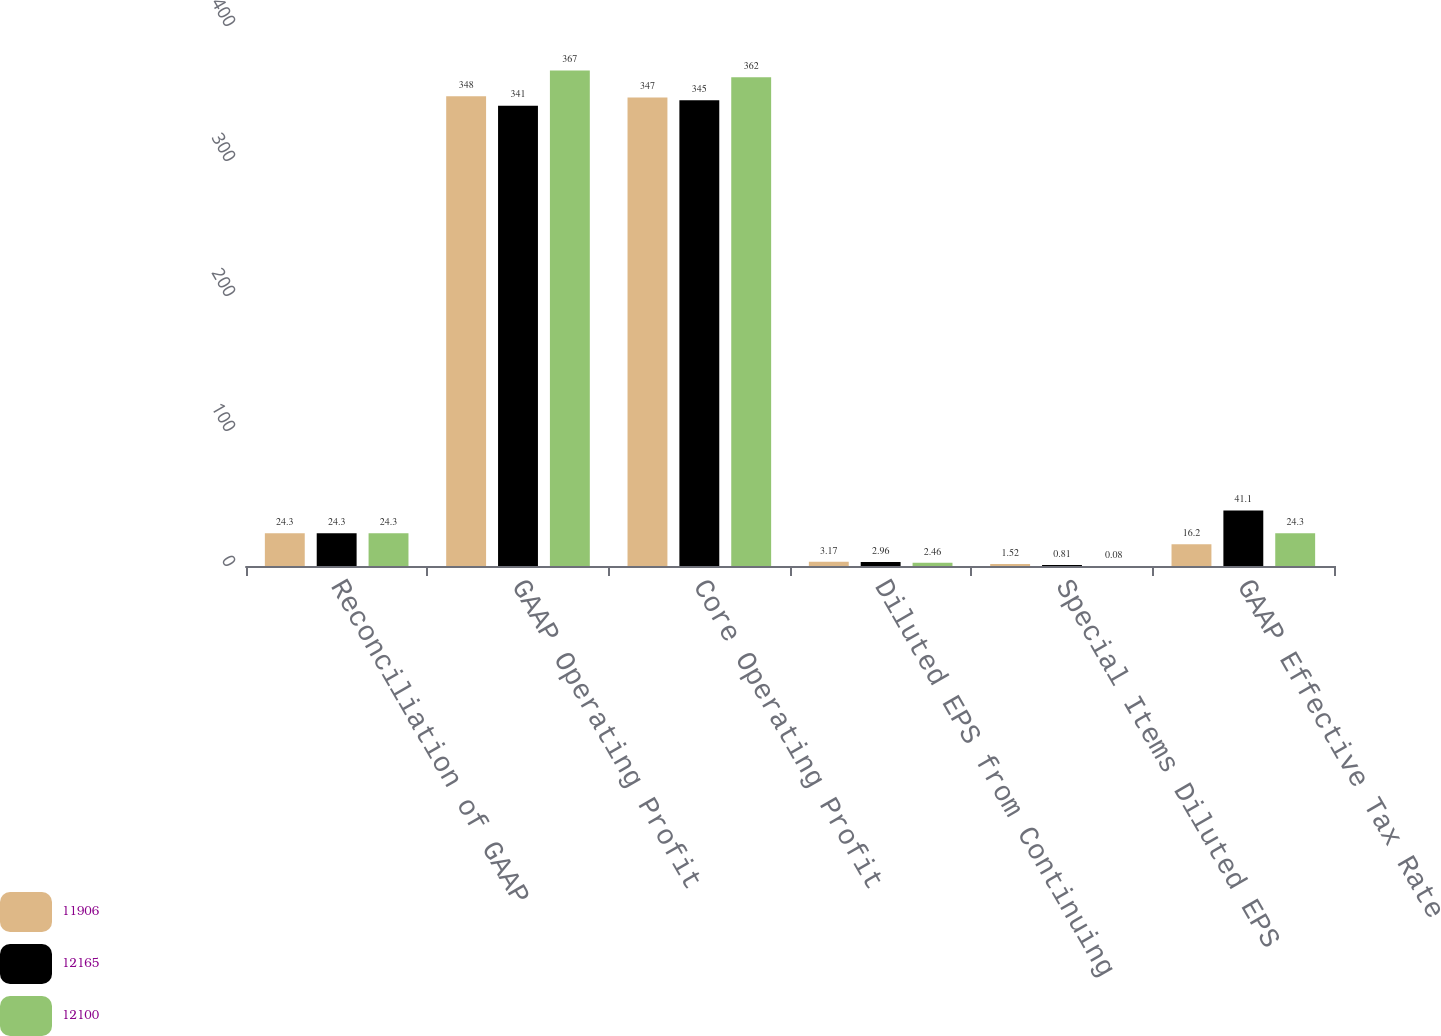<chart> <loc_0><loc_0><loc_500><loc_500><stacked_bar_chart><ecel><fcel>Reconciliation of GAAP<fcel>GAAP Operating Profit<fcel>Core Operating Profit<fcel>Diluted EPS from Continuing<fcel>Special Items Diluted EPS<fcel>GAAP Effective Tax Rate<nl><fcel>11906<fcel>24.3<fcel>348<fcel>347<fcel>3.17<fcel>1.52<fcel>16.2<nl><fcel>12165<fcel>24.3<fcel>341<fcel>345<fcel>2.96<fcel>0.81<fcel>41.1<nl><fcel>12100<fcel>24.3<fcel>367<fcel>362<fcel>2.46<fcel>0.08<fcel>24.3<nl></chart> 